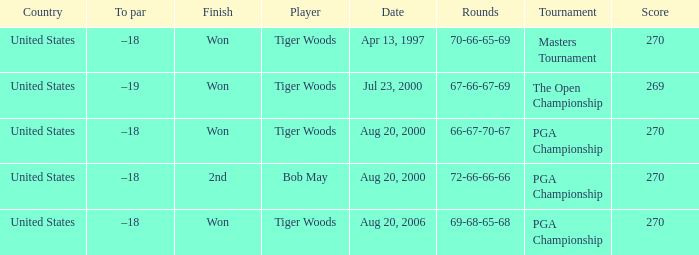What is the worst (highest) score? 270.0. Would you mind parsing the complete table? {'header': ['Country', 'To par', 'Finish', 'Player', 'Date', 'Rounds', 'Tournament', 'Score'], 'rows': [['United States', '–18', 'Won', 'Tiger Woods', 'Apr 13, 1997', '70-66-65-69', 'Masters Tournament', '270'], ['United States', '–19', 'Won', 'Tiger Woods', 'Jul 23, 2000', '67-66-67-69', 'The Open Championship', '269'], ['United States', '–18', 'Won', 'Tiger Woods', 'Aug 20, 2000', '66-67-70-67', 'PGA Championship', '270'], ['United States', '–18', '2nd', 'Bob May', 'Aug 20, 2000', '72-66-66-66', 'PGA Championship', '270'], ['United States', '–18', 'Won', 'Tiger Woods', 'Aug 20, 2006', '69-68-65-68', 'PGA Championship', '270']]} 